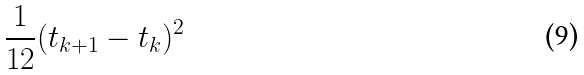<formula> <loc_0><loc_0><loc_500><loc_500>\frac { 1 } { 1 2 } ( t _ { k + 1 } - t _ { k } ) ^ { 2 }</formula> 